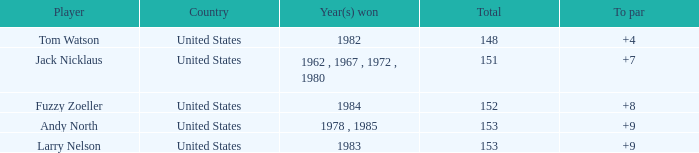In which country does the player with a cumulative score below 153 and a winning year of 1984 originate? United States. 